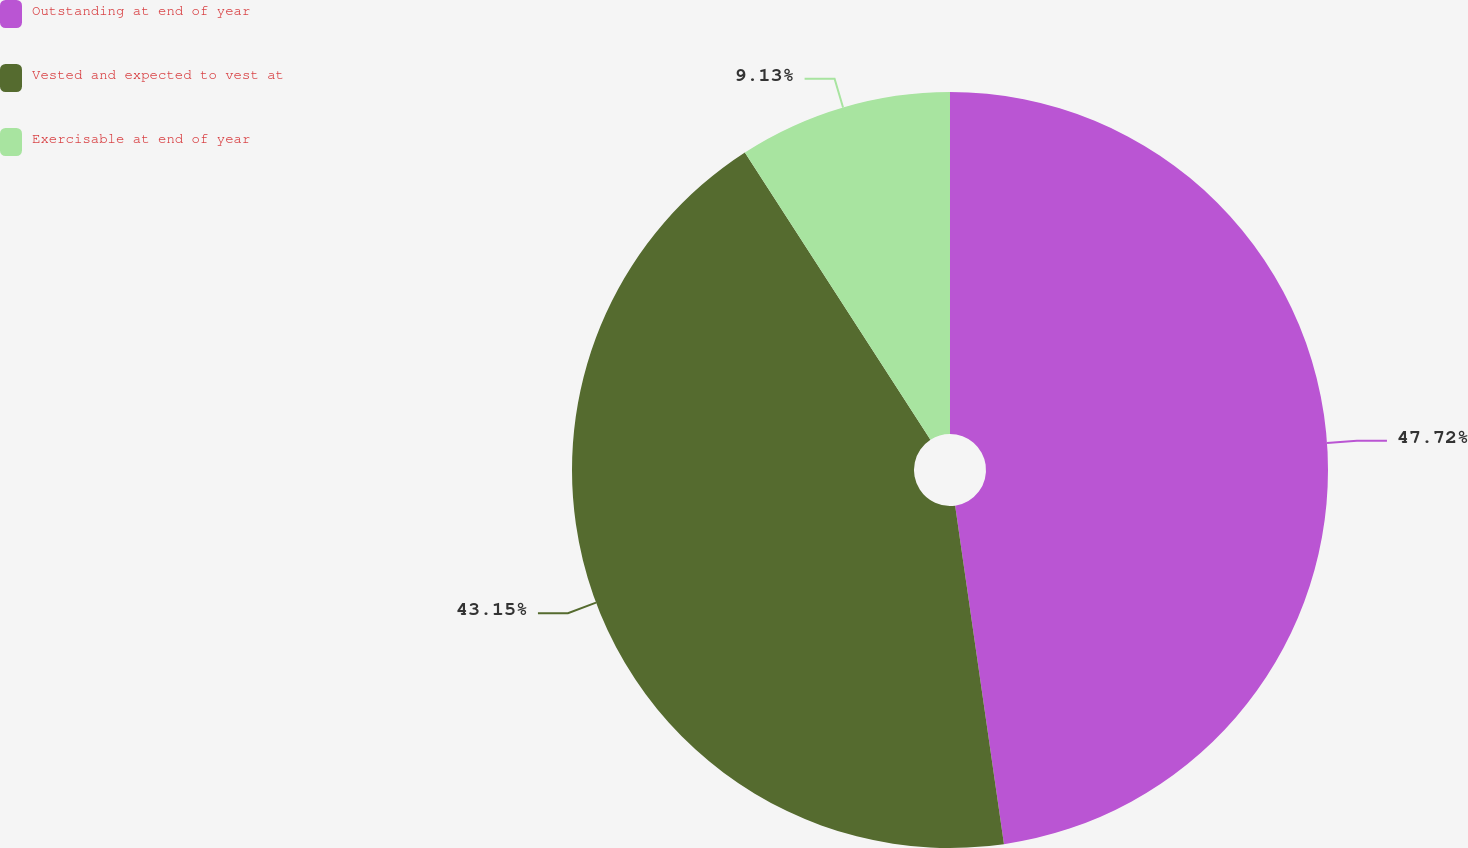Convert chart. <chart><loc_0><loc_0><loc_500><loc_500><pie_chart><fcel>Outstanding at end of year<fcel>Vested and expected to vest at<fcel>Exercisable at end of year<nl><fcel>47.72%<fcel>43.15%<fcel>9.13%<nl></chart> 